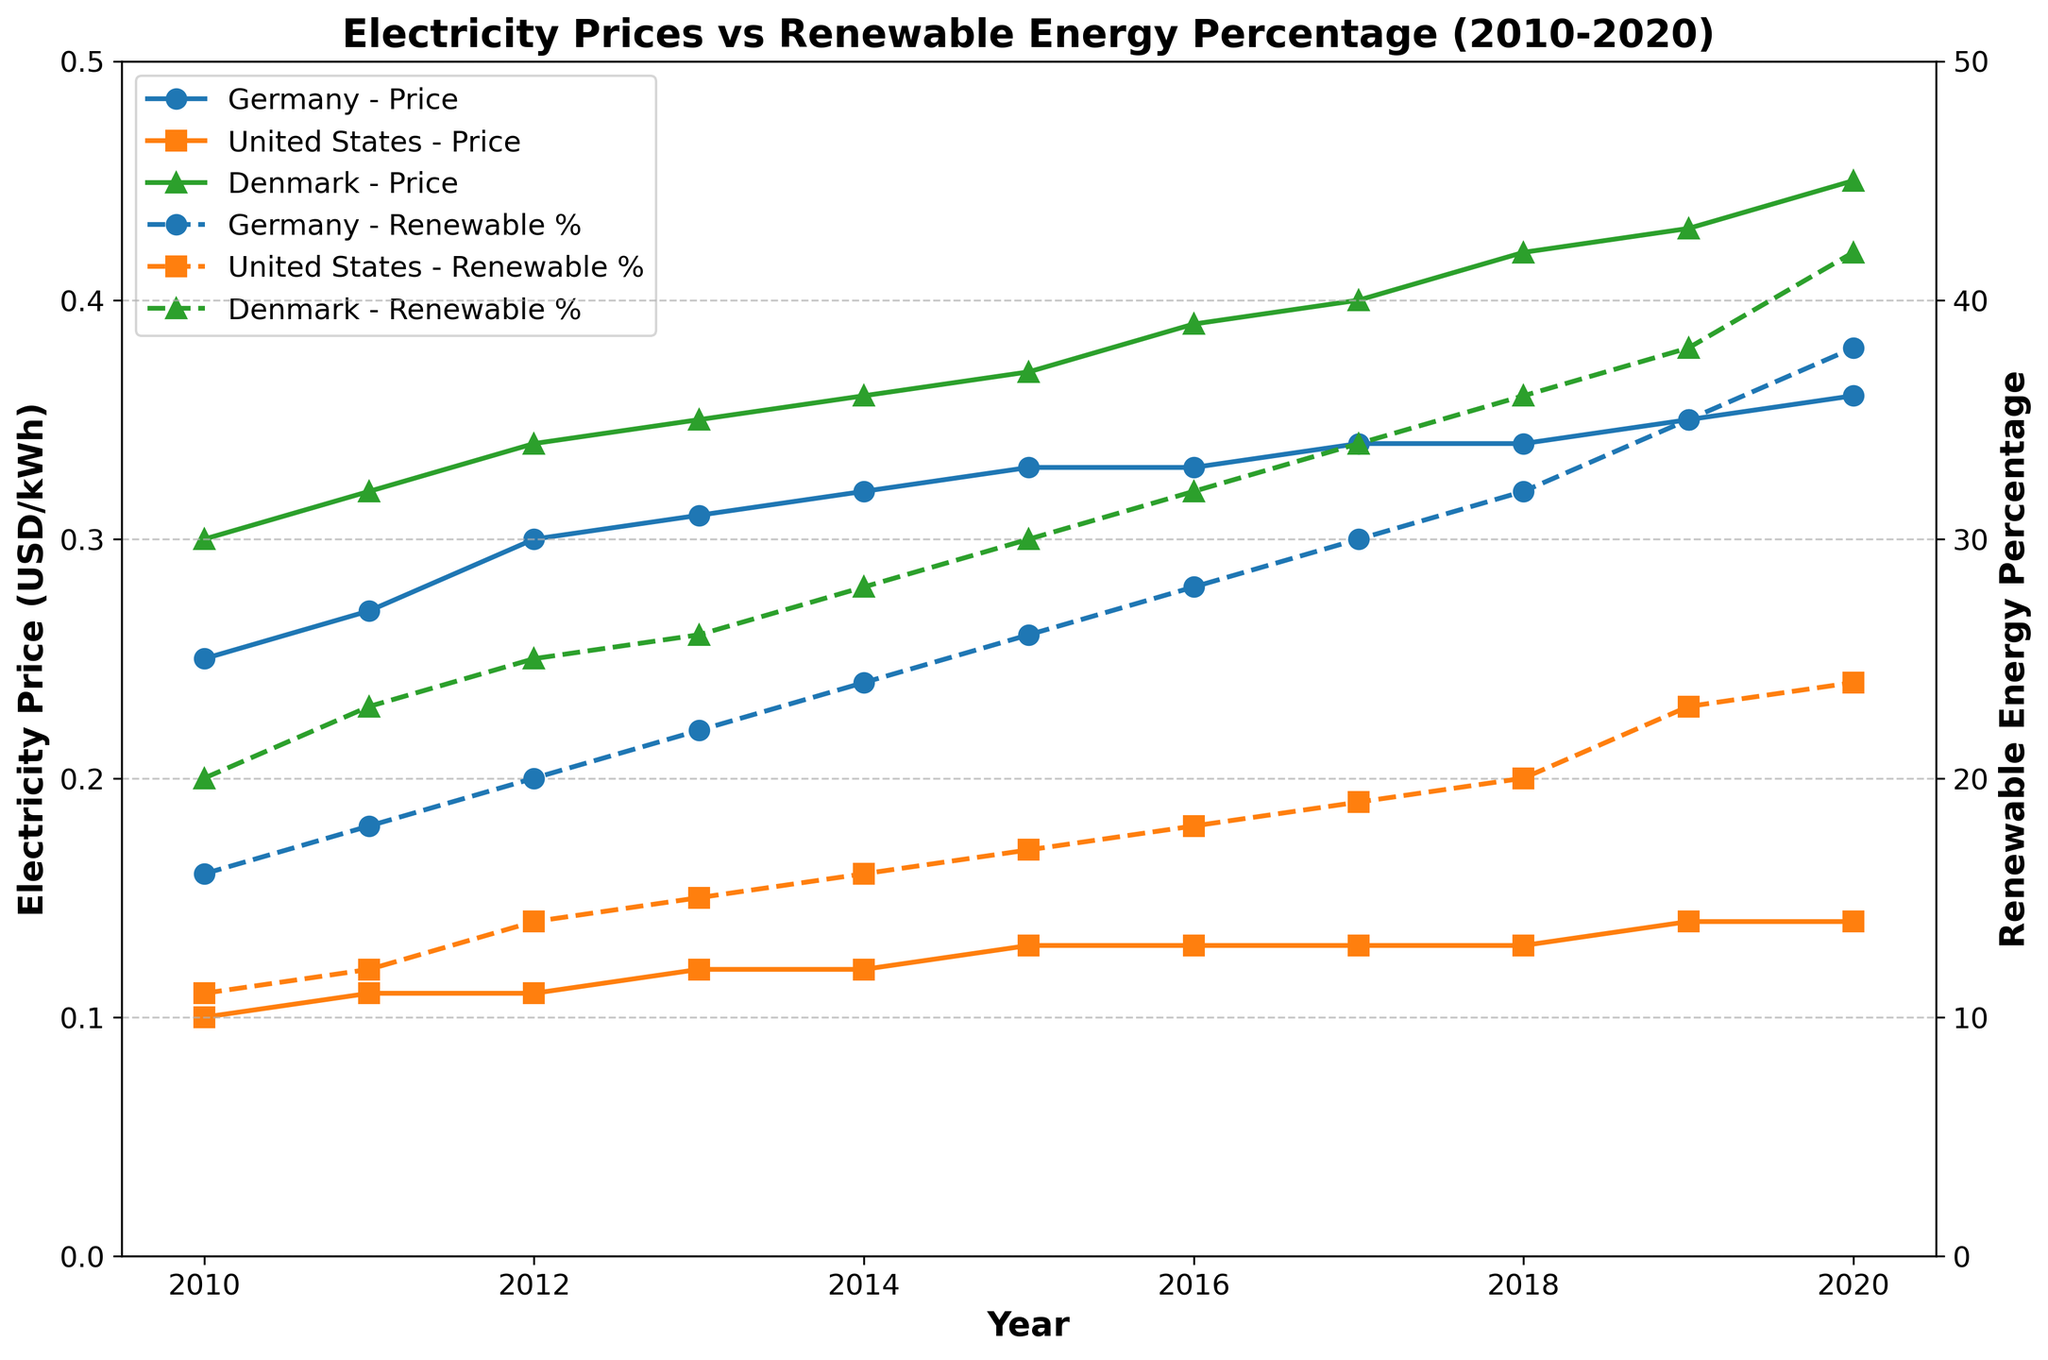What is the title of the figure? The title of the figure is written at the top. It reads 'Electricity Prices vs Renewable Energy Percentage (2010-2020)'.
Answer: Electricity Prices vs Renewable Energy Percentage (2010-2020) Which country had the highest electricity price in 2020? Observing the plots, the highest electricity price in 2020 is in Denmark, which is marked by the blue 'o' marker at 0.45 USD/kWh.
Answer: Denmark How did the renewable energy percentage in Germany change from 2010 to 2020? By tracking the dashed line for Germany, the renewable energy percentage increased from 16% in 2010 to 38% in 2020.
Answer: Increased from 16% to 38% Which country had the smallest increase in electricity price from 2010 to 2020? By checking the solid lines of each country, the United States had the smallest increase, from 0.10 USD/kWh in 2010 to 0.14 USD/kWh in 2020, an increase of 0.04 USD/kWh.
Answer: United States Compare the renewable energy growth trends between Germany and Denmark from 2010 to 2020. For Germany, the renewable energy percentage grew from 16% to 38%, while Denmark's went from 20% to 42%. Denmark had a steeper growth rate in renewable energy compared to Germany.
Answer: Denmark grew faster What was the electricity price difference between the United States and Germany in 2015? In 2015, the electricity price for Germany was 0.33 USD/kWh, and for the United States, it was 0.13 USD/kWh. The difference is 0.33 - 0.13 = 0.20 USD/kWh.
Answer: 0.20 USD/kWh In which year did Germany and Denmark have the same electricity price, and what was that price? Germany and Denmark had the same electricity price of 0.32 USD/kWh in the year 2011.
Answer: 2011, 0.32 USD/kWh What is the percentage increase in renewable energy in the United States from 2010 to 2020? The renewable energy percentage in the United States increased from 11% in 2010 to 24% in 2020. The percentage increase is ((24 - 11) / 11) * 100 = 118.18%.
Answer: 118.18% Which country had the highest renewable energy percentage in 2017, and what was it? In 2017, Denmark had the highest renewable energy percentage at 34%.
Answer: Denmark, 34% 